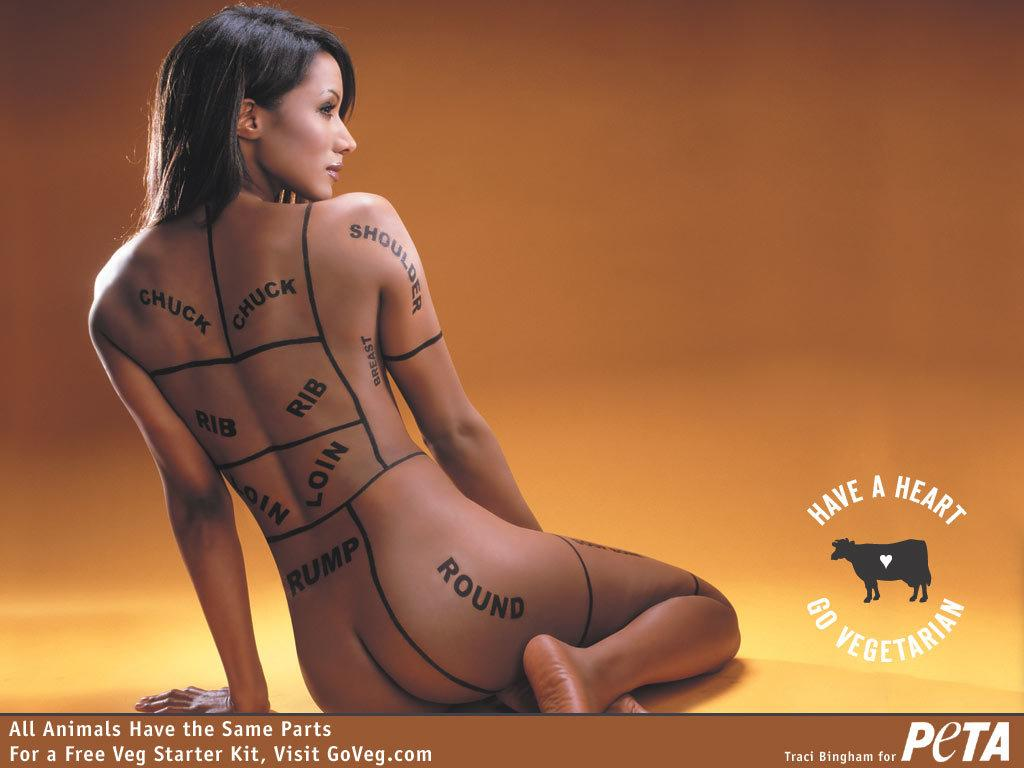Who is present in the image? There is a woman in the image. What can be found in the bottom right corner of the image? There is a logo in the bottom right corner of the image. What is located at the bottom of the image? There is text at the bottom of the image. What type of eggs can be seen in the woman's hobbies in the image? There are no eggs or references to hobbies in the image. 